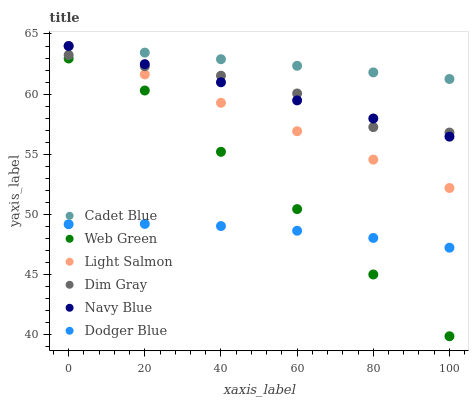Does Dodger Blue have the minimum area under the curve?
Answer yes or no. Yes. Does Cadet Blue have the maximum area under the curve?
Answer yes or no. Yes. Does Dim Gray have the minimum area under the curve?
Answer yes or no. No. Does Dim Gray have the maximum area under the curve?
Answer yes or no. No. Is Navy Blue the smoothest?
Answer yes or no. Yes. Is Dim Gray the roughest?
Answer yes or no. Yes. Is Dim Gray the smoothest?
Answer yes or no. No. Is Navy Blue the roughest?
Answer yes or no. No. Does Web Green have the lowest value?
Answer yes or no. Yes. Does Dim Gray have the lowest value?
Answer yes or no. No. Does Cadet Blue have the highest value?
Answer yes or no. Yes. Does Dim Gray have the highest value?
Answer yes or no. No. Is Dodger Blue less than Cadet Blue?
Answer yes or no. Yes. Is Navy Blue greater than Web Green?
Answer yes or no. Yes. Does Navy Blue intersect Dim Gray?
Answer yes or no. Yes. Is Navy Blue less than Dim Gray?
Answer yes or no. No. Is Navy Blue greater than Dim Gray?
Answer yes or no. No. Does Dodger Blue intersect Cadet Blue?
Answer yes or no. No. 